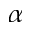Convert formula to latex. <formula><loc_0><loc_0><loc_500><loc_500>\alpha</formula> 